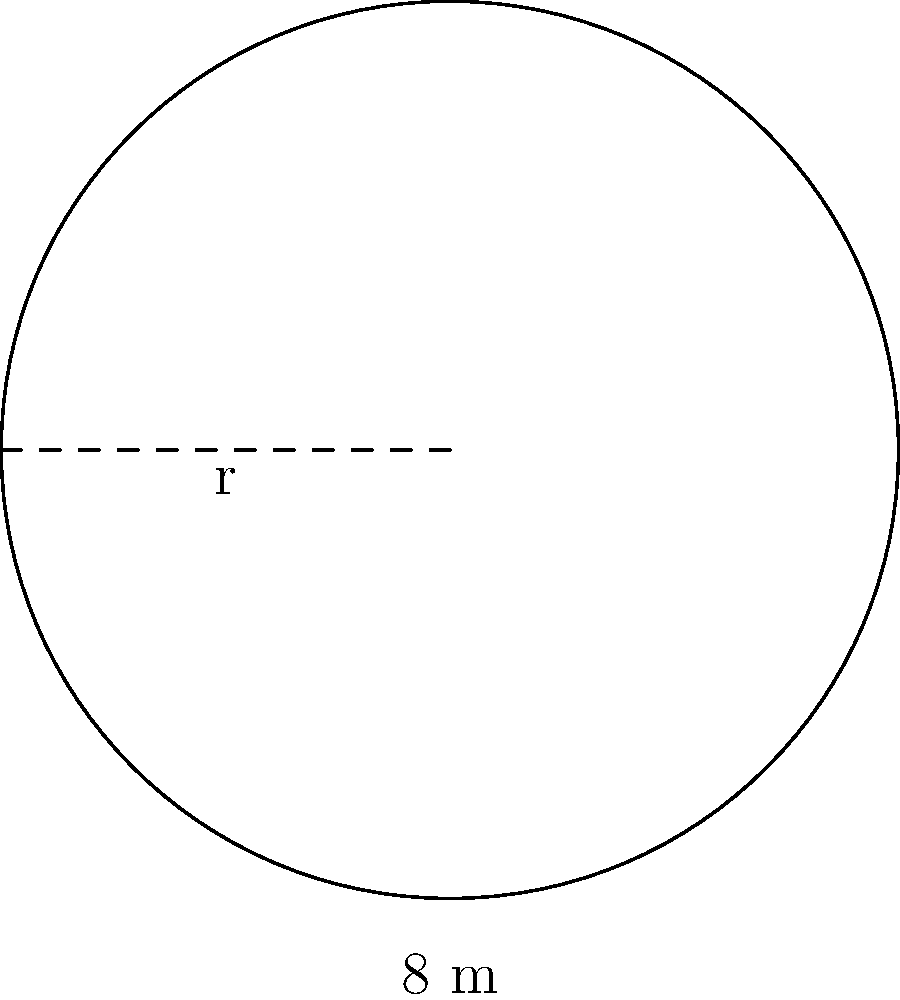You need to install a protective barrier around a circular storage tank for your raw materials. The tank has a diameter of 8 meters. What is the minimum length of fencing required to completely enclose the tank, allowing for a 10% safety margin? To solve this problem, we'll follow these steps:

1) First, we need to calculate the circumference of the tank:
   - The diameter is 8 meters, so the radius is 4 meters
   - The formula for circumference is $C = 2\pi r$
   - $C = 2 \times \pi \times 4 = 8\pi$ meters

2) Now, we need to add a 10% safety margin:
   - 10% of $8\pi$ is $0.1 \times 8\pi = 0.8\pi$
   - Total length needed: $8\pi + 0.8\pi = 8.8\pi$ meters

3) Let's calculate this value:
   $8.8\pi \approx 27.65$ meters

Therefore, you'll need approximately 27.65 meters of fencing to enclose the tank with a 10% safety margin.
Answer: $27.65$ meters 